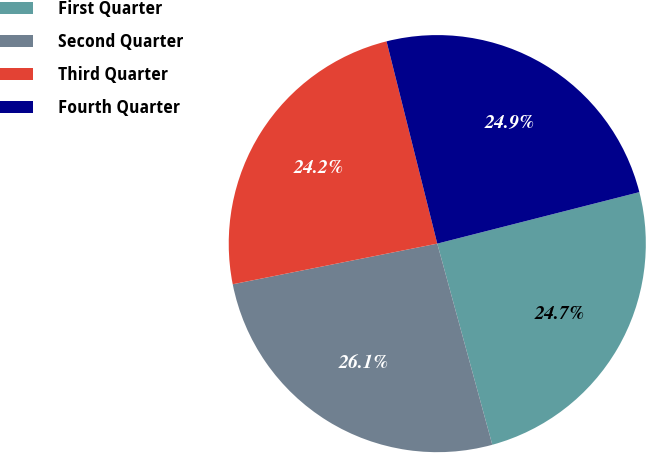<chart> <loc_0><loc_0><loc_500><loc_500><pie_chart><fcel>First Quarter<fcel>Second Quarter<fcel>Third Quarter<fcel>Fourth Quarter<nl><fcel>24.72%<fcel>26.13%<fcel>24.21%<fcel>24.94%<nl></chart> 